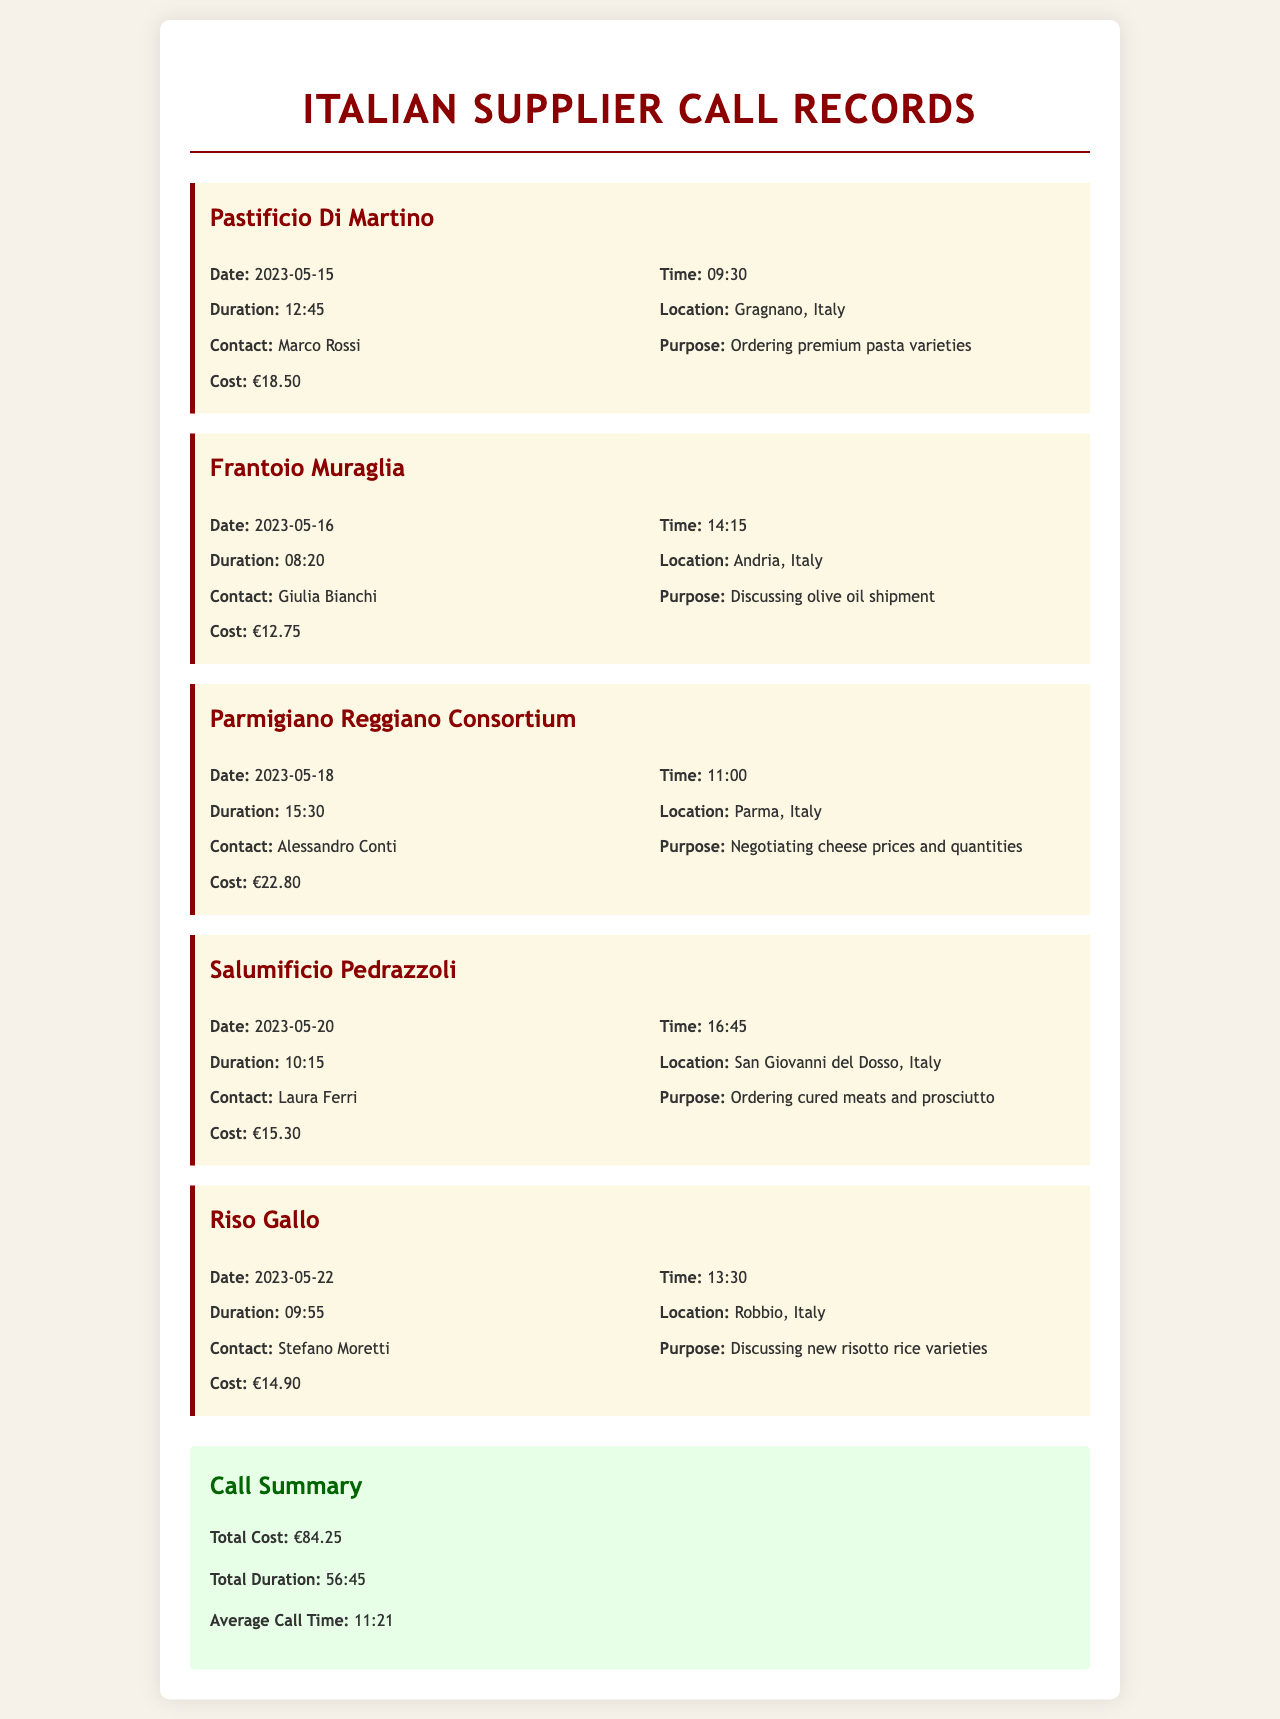What supplier was called on May 15, 2023? The document lists Pastificio Di Martino as the supplier called on that date.
Answer: Pastificio Di Martino What was the purpose of the call to Frantoio Muraglia? The purpose mentioned is to discuss the olive oil shipment with Giulia Bianchi.
Answer: Discussing olive oil shipment What is the total cost of all calls? The summary at the end of the document states the total cost of all calls made.
Answer: €84.25 How long was the call with Parmigiano Reggiano Consortium? The duration of the call is provided as 15:30.
Answer: 15:30 Who did the call on May 20, 2023, target? The call on that date targeted Salumificio Pedrazzoli, as indicated in the document.
Answer: Salumificio Pedrazzoli What was the average call time noted in the document? The average call time is calculated based on the total duration of all calls.
Answer: 11:21 Which supplier is located in Parma, Italy? The document specifies Parmigiano Reggiano Consortium as the supplier located in Parma.
Answer: Parmigiano Reggiano Consortium How much did the call with Riso Gallo cost? The specific cost of that call is listed in the details for Riso Gallo.
Answer: €14.90 What is the location of Frantoio Muraglia? The document states that Frantoio Muraglia is located in Andria, Italy.
Answer: Andria, Italy 